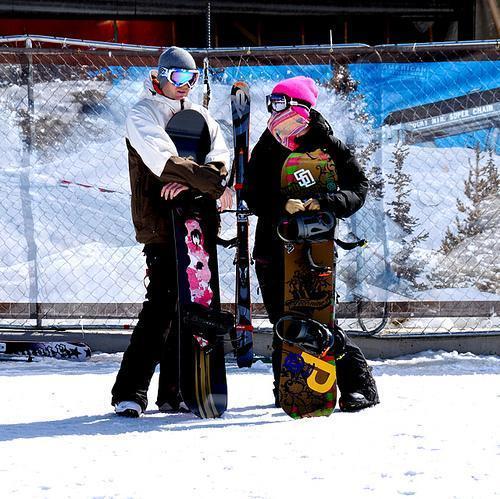How many people are visible?
Give a very brief answer. 2. How many people are in the photo?
Give a very brief answer. 2. How many snowboards are there?
Give a very brief answer. 2. 